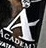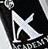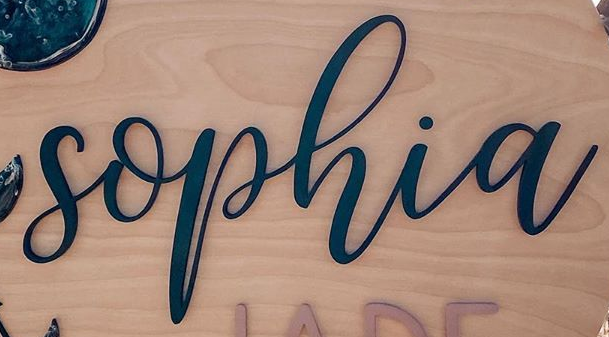What text appears in these images from left to right, separated by a semicolon? A; A; sophia 